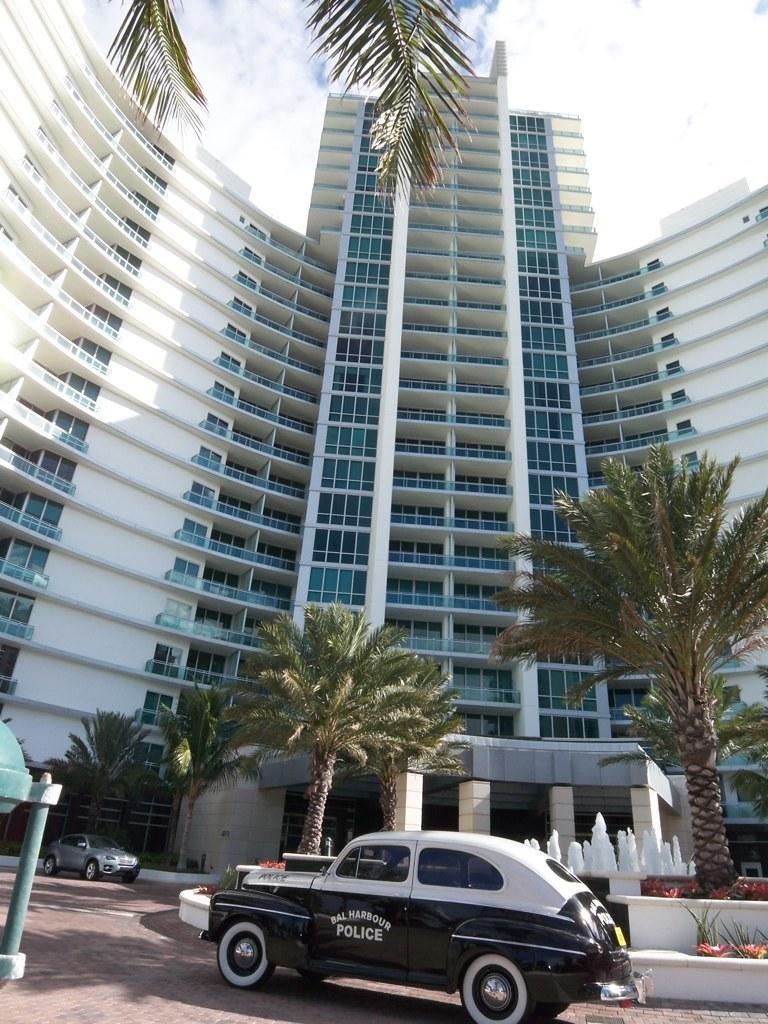Please provide a concise description of this image. In this image there are two cars in the bottom of this image and there are some trees in the background. There is a building in middle of this image and there are some leaves as we can see on the top left side of this image and there is a sky on the top of this image. 